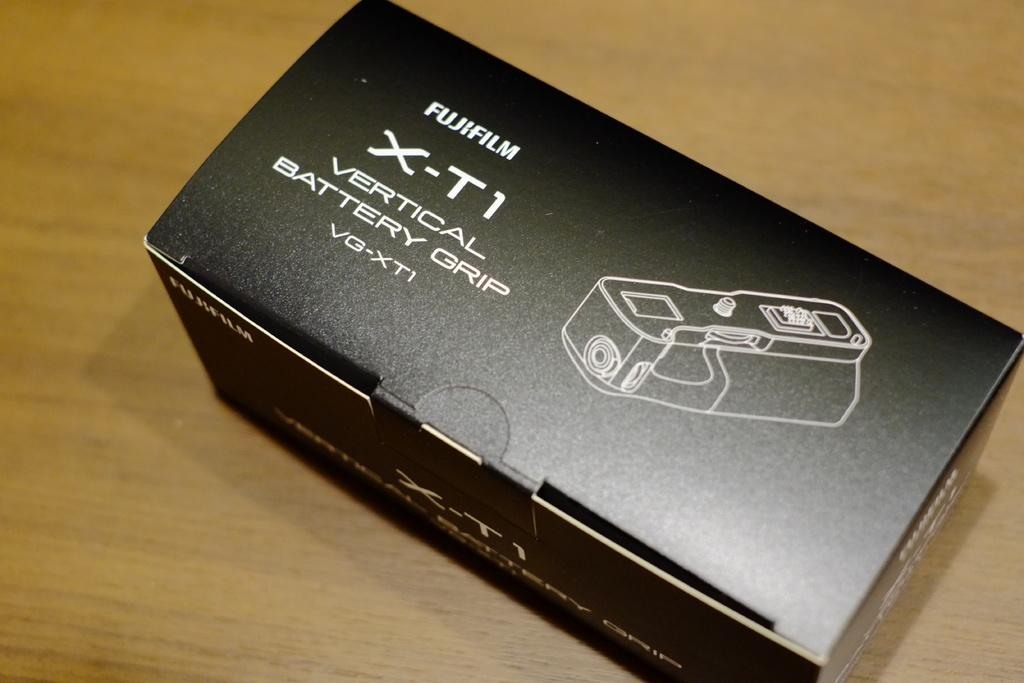<image>
Offer a succinct explanation of the picture presented. A black Fujifilm box sits on a table. 